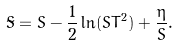Convert formula to latex. <formula><loc_0><loc_0><loc_500><loc_500>\tilde { S } = S - \frac { 1 } { 2 } \ln ( S T ^ { 2 } ) + \frac { \eta } { S } .</formula> 